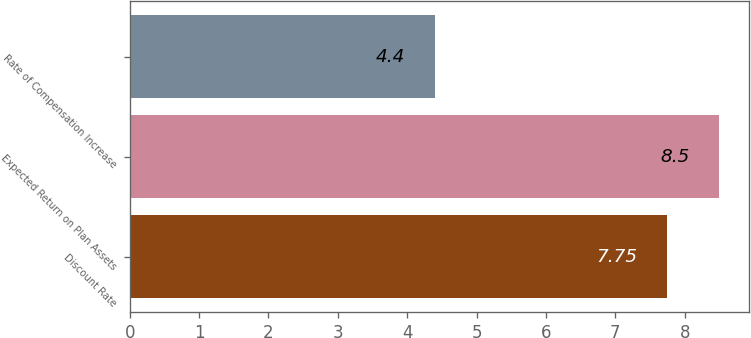<chart> <loc_0><loc_0><loc_500><loc_500><bar_chart><fcel>Discount Rate<fcel>Expected Return on Plan Assets<fcel>Rate of Compensation Increase<nl><fcel>7.75<fcel>8.5<fcel>4.4<nl></chart> 